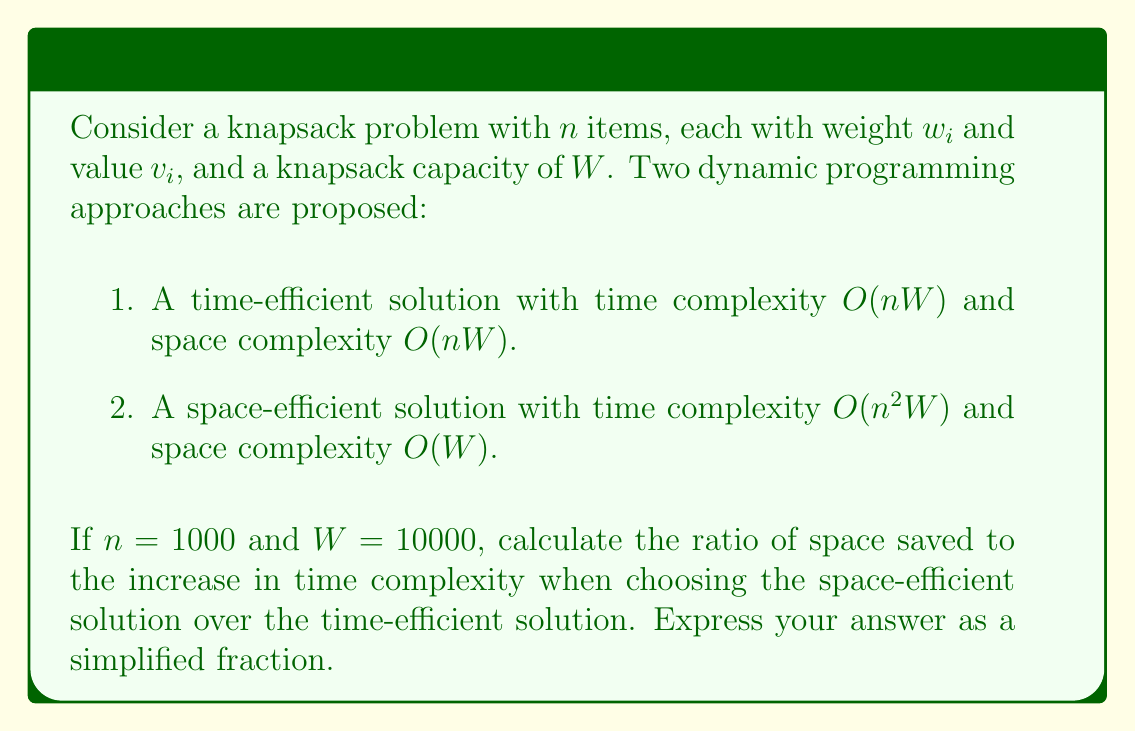Show me your answer to this math problem. Let's approach this step-by-step:

1) First, let's calculate the time and space complexities for both solutions:

   Time-efficient solution:
   - Time: $O(nW) = O(1000 \times 10000) = O(10^7)$
   - Space: $O(nW) = O(1000 \times 10000) = O(10^7)$

   Space-efficient solution:
   - Time: $O(n^2W) = O(1000^2 \times 10000) = O(10^{10})$
   - Space: $O(W) = O(10000) = O(10^4)$

2) Now, let's calculate the space saved:
   $10^7 - 10^4 = 9999000$

3) And the increase in time complexity:
   $10^{10} - 10^7 = 9999000000$

4) The ratio of space saved to time increase is:
   $\frac{9999000}{9999000000} = \frac{1}{1000}$

This ratio represents the tradeoff between space savings and time increase. For every unit of space saved, we incur 1000 units of additional time complexity.
Answer: $\frac{1}{1000}$ 